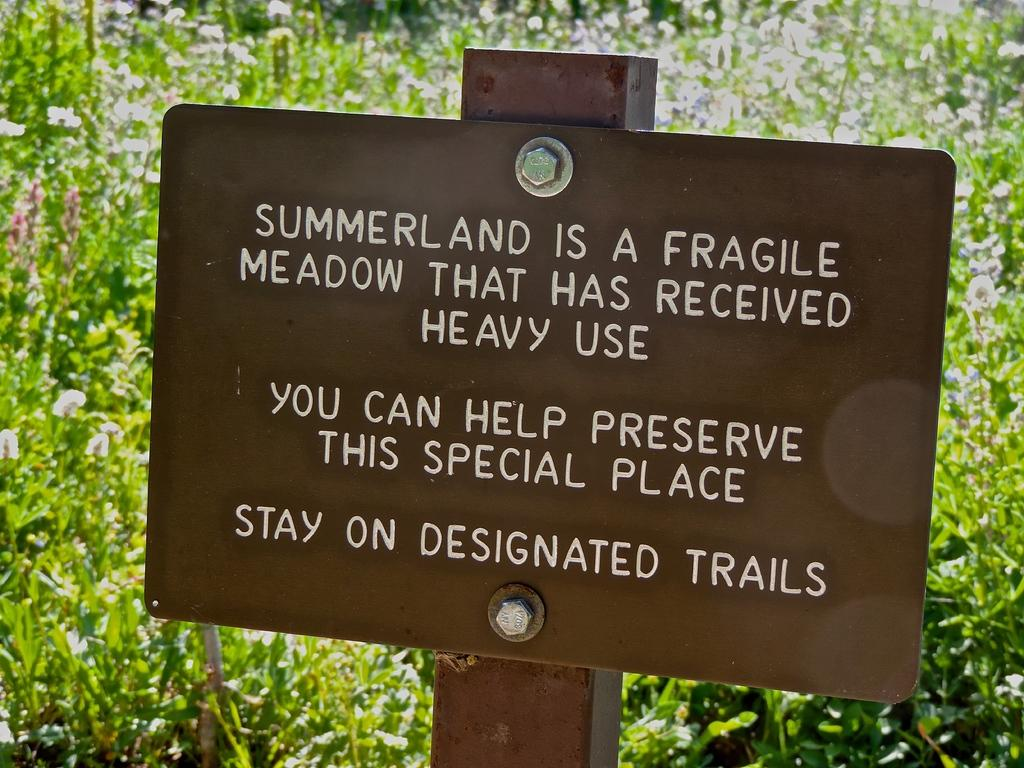What material is the board in the image made of? The board in the image is made of metal. How is the board attached to the pole? The board is fixed to a pole using bolts. What can be seen in the background of the image? There are plants in the background of the image. What type of skirt is the airport wearing in the image? There is no airport present in the image, and therefore no skirt can be observed. 